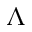Convert formula to latex. <formula><loc_0><loc_0><loc_500><loc_500>\Lambda</formula> 